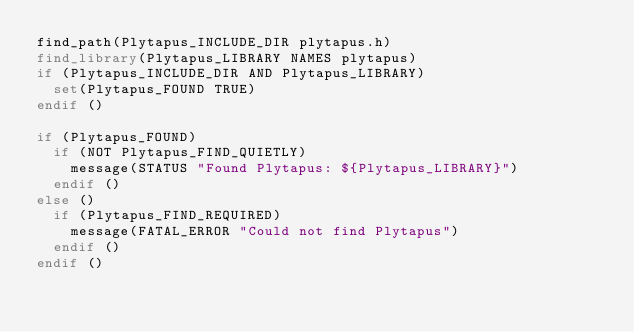Convert code to text. <code><loc_0><loc_0><loc_500><loc_500><_CMake_>find_path(Plytapus_INCLUDE_DIR plytapus.h)
find_library(Plytapus_LIBRARY NAMES plytapus)
if (Plytapus_INCLUDE_DIR AND Plytapus_LIBRARY)
  set(Plytapus_FOUND TRUE)
endif ()

if (Plytapus_FOUND)
  if (NOT Plytapus_FIND_QUIETLY)
    message(STATUS "Found Plytapus: ${Plytapus_LIBRARY}")
  endif ()
else ()
  if (Plytapus_FIND_REQUIRED)
    message(FATAL_ERROR "Could not find Plytapus")
  endif ()
endif ()
</code> 